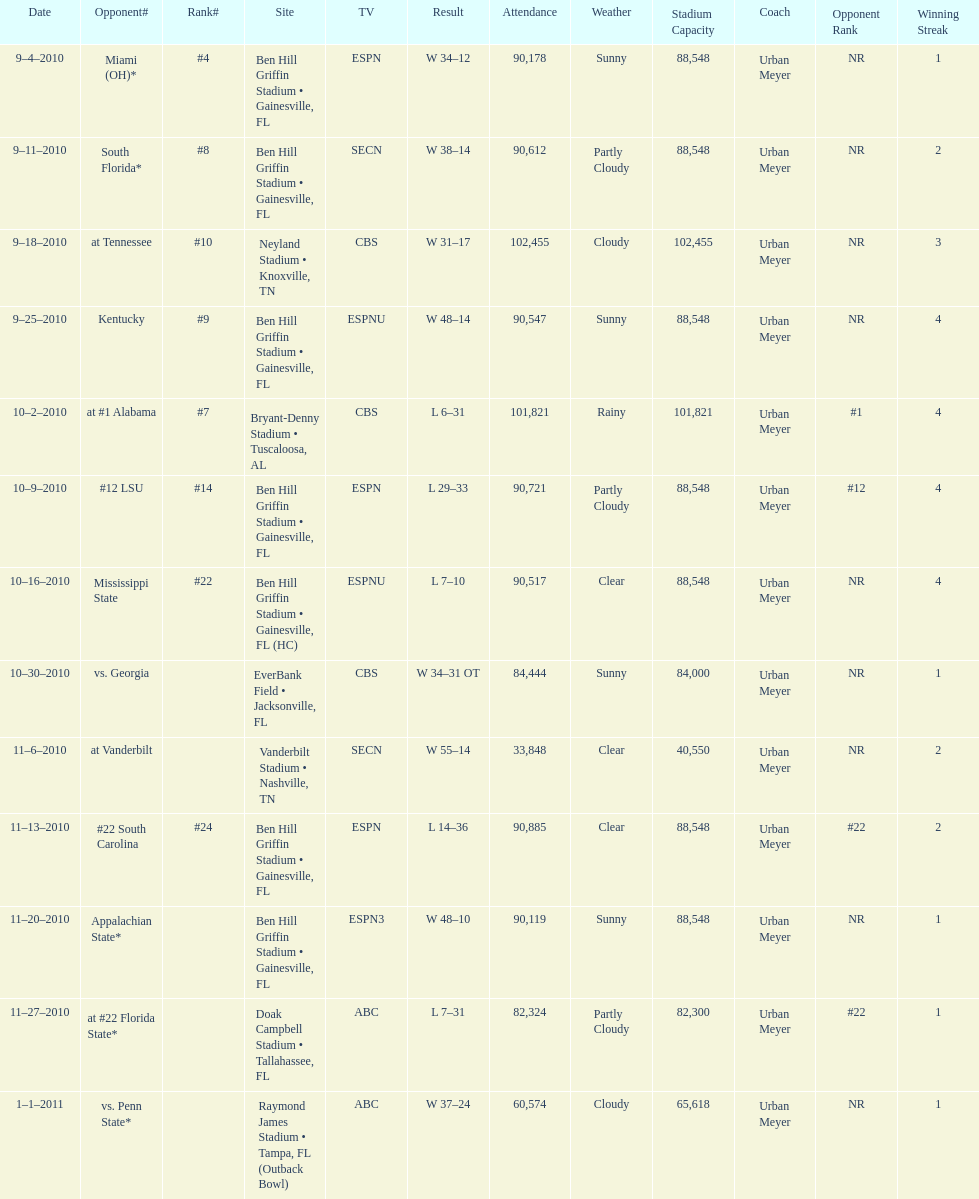What is the number of games played in teh 2010-2011 season 13. 